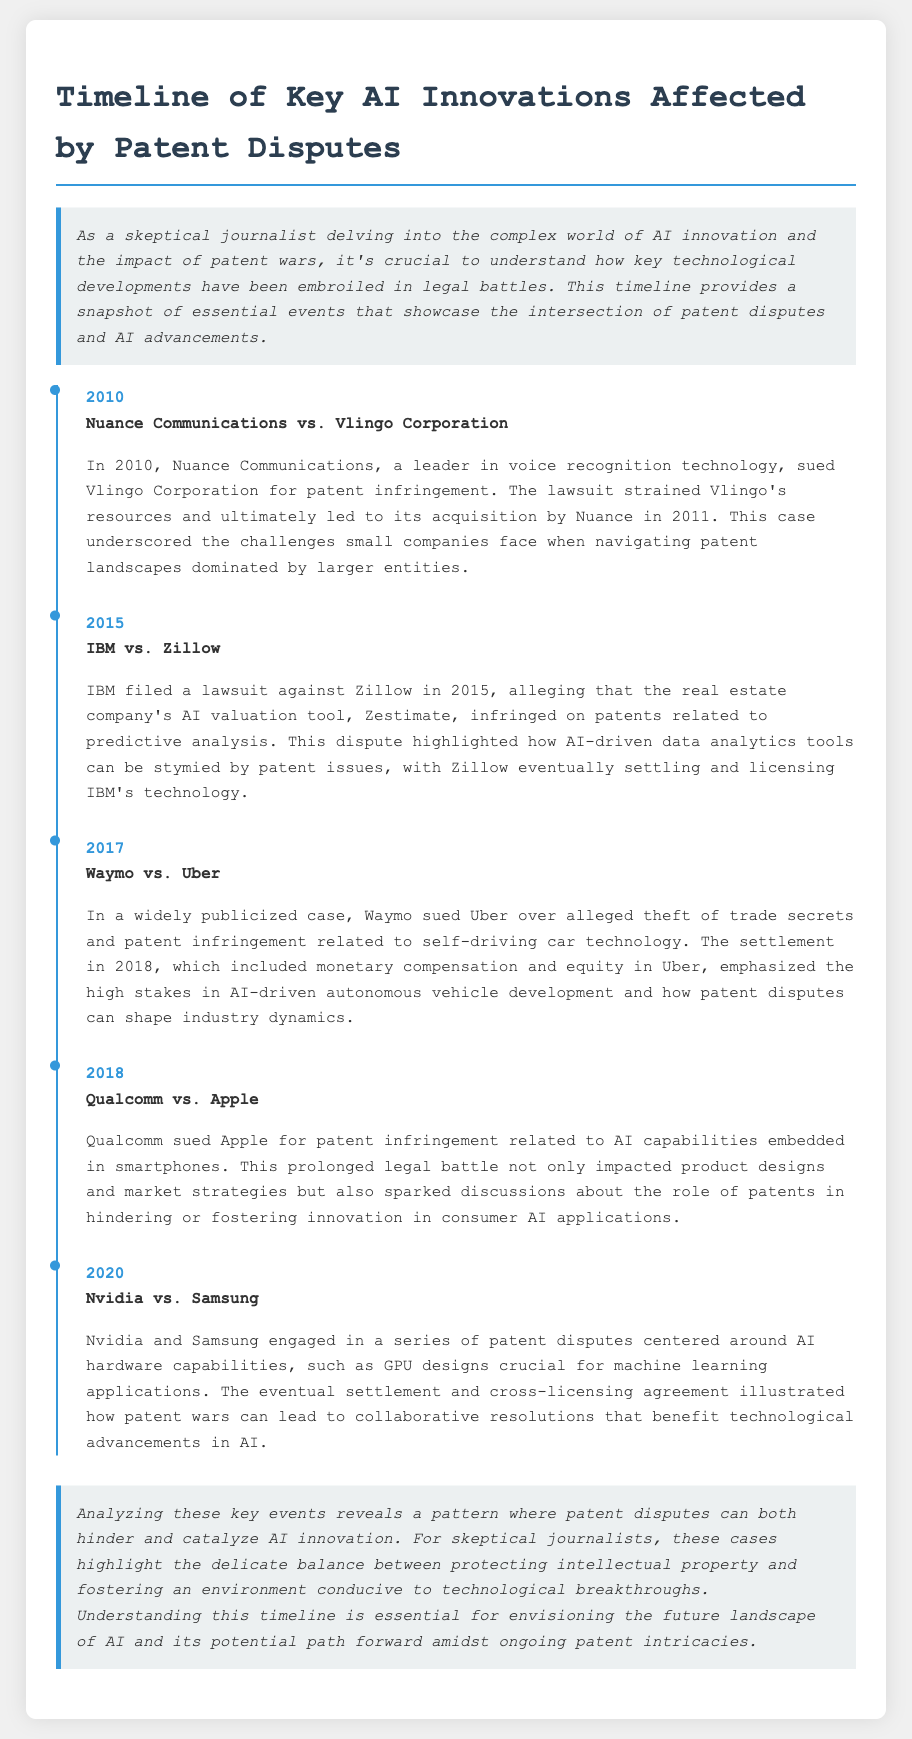What year did Nuance Communications sue Vlingo Corporation? The document states that the lawsuit occurred in 2010.
Answer: 2010 What was the main technology involved in the IBM vs. Zillow case? The lawsuit was related to a predictive analysis tool used by Zillow.
Answer: Predictive analysis Who acquired Vlingo Corporation? The document indicates that Nuance Communications acquired Vlingo Corporation in 2011.
Answer: Nuance Communications What was the result of the Waymo vs. Uber case? The settlement included monetary compensation and equity in Uber.
Answer: Monetary compensation and equity in Uber Which two companies were involved in a patent dispute over smartphone AI capabilities? Qualcomm sued Apple over patent infringement related to AI in smartphones.
Answer: Qualcomm and Apple What type of resolution was reached in the Nvidia vs. Samsung dispute? The document notes that a settlement and cross-licensing agreement were reached.
Answer: Cross-licensing agreement How did the Qualcomm vs. Apple case impact market strategies? The document explains that it impacted product designs and market strategies.
Answer: Impacted product designs and market strategies What does the timeline suggest about the impact of patent disputes on AI innovation? The document discusses a pattern where disputes can both hinder and catalyze innovation.
Answer: Hinder and catalyze innovation 